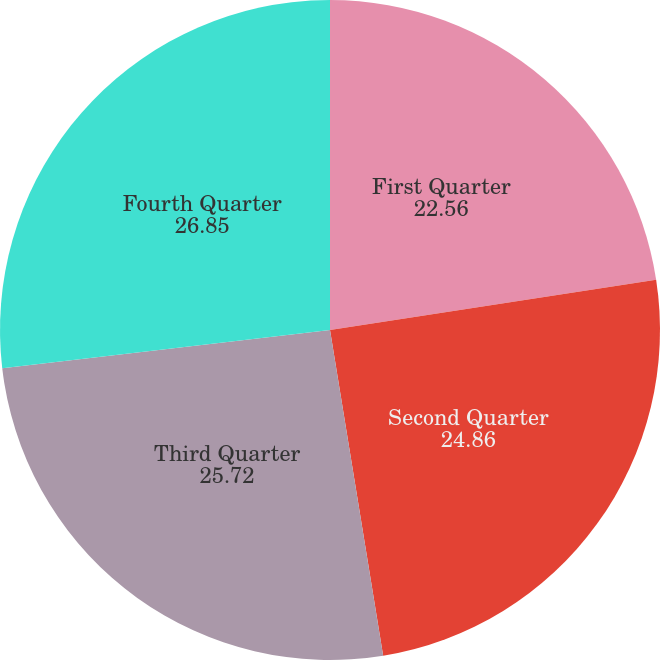Convert chart to OTSL. <chart><loc_0><loc_0><loc_500><loc_500><pie_chart><fcel>First Quarter<fcel>Second Quarter<fcel>Third Quarter<fcel>Fourth Quarter<nl><fcel>22.56%<fcel>24.86%<fcel>25.72%<fcel>26.85%<nl></chart> 